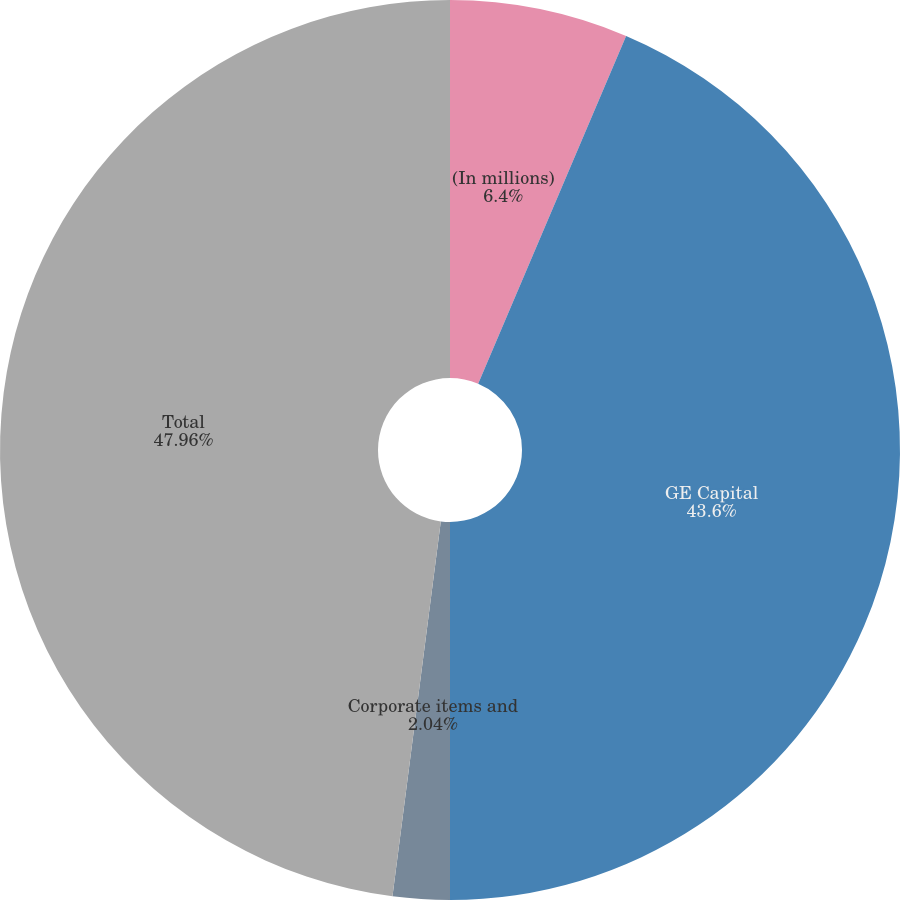Convert chart. <chart><loc_0><loc_0><loc_500><loc_500><pie_chart><fcel>(In millions)<fcel>GE Capital<fcel>Corporate items and<fcel>Total<nl><fcel>6.4%<fcel>43.6%<fcel>2.04%<fcel>47.96%<nl></chart> 